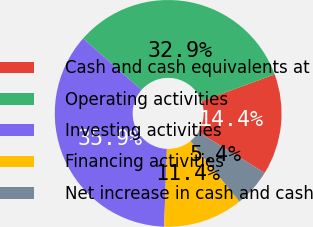Convert chart to OTSL. <chart><loc_0><loc_0><loc_500><loc_500><pie_chart><fcel>Cash and cash equivalents at<fcel>Operating activities<fcel>Investing activities<fcel>Financing activities<fcel>Net increase in cash and cash<nl><fcel>14.38%<fcel>32.92%<fcel>35.92%<fcel>11.38%<fcel>5.39%<nl></chart> 